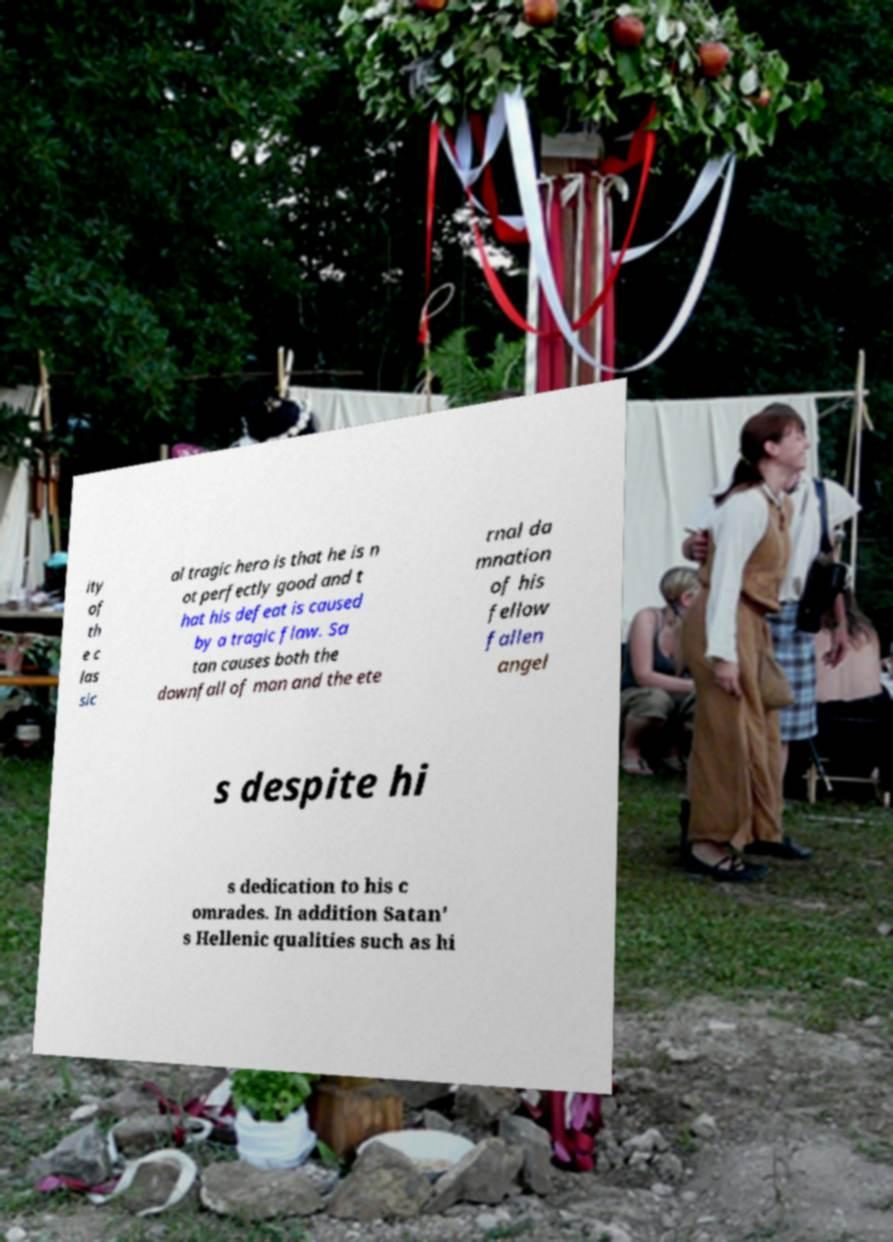Could you assist in decoding the text presented in this image and type it out clearly? ity of th e c las sic al tragic hero is that he is n ot perfectly good and t hat his defeat is caused by a tragic flaw. Sa tan causes both the downfall of man and the ete rnal da mnation of his fellow fallen angel s despite hi s dedication to his c omrades. In addition Satan' s Hellenic qualities such as hi 